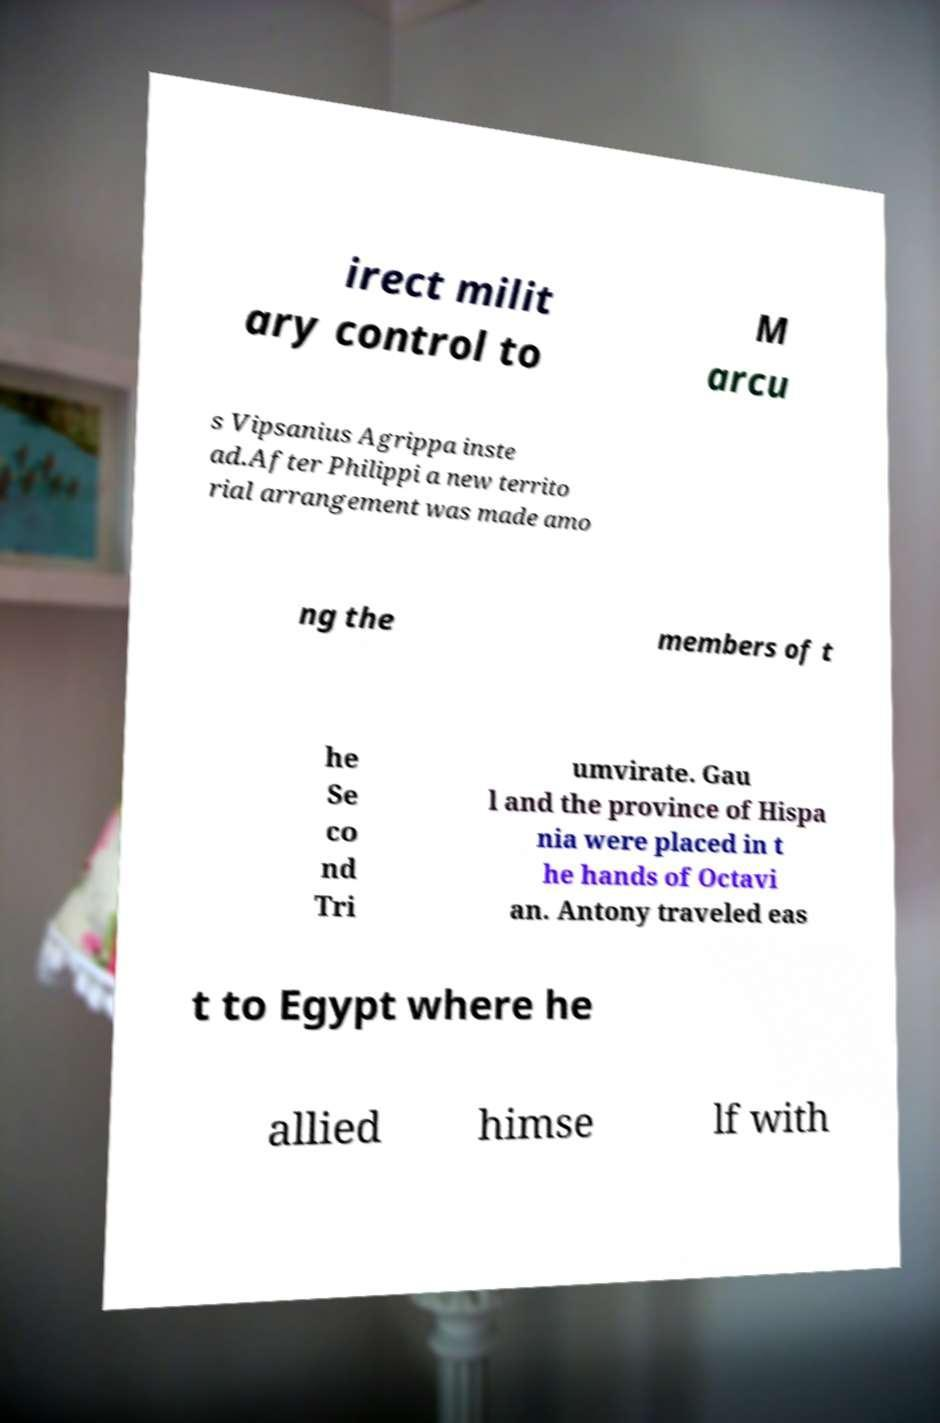What messages or text are displayed in this image? I need them in a readable, typed format. irect milit ary control to M arcu s Vipsanius Agrippa inste ad.After Philippi a new territo rial arrangement was made amo ng the members of t he Se co nd Tri umvirate. Gau l and the province of Hispa nia were placed in t he hands of Octavi an. Antony traveled eas t to Egypt where he allied himse lf with 